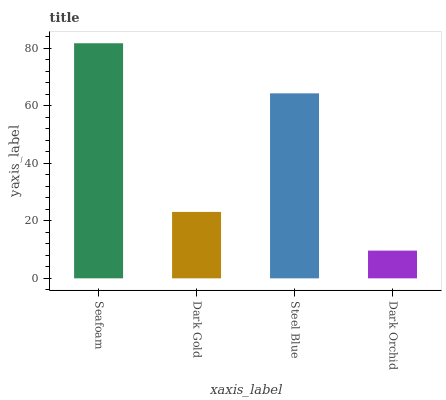Is Dark Orchid the minimum?
Answer yes or no. Yes. Is Seafoam the maximum?
Answer yes or no. Yes. Is Dark Gold the minimum?
Answer yes or no. No. Is Dark Gold the maximum?
Answer yes or no. No. Is Seafoam greater than Dark Gold?
Answer yes or no. Yes. Is Dark Gold less than Seafoam?
Answer yes or no. Yes. Is Dark Gold greater than Seafoam?
Answer yes or no. No. Is Seafoam less than Dark Gold?
Answer yes or no. No. Is Steel Blue the high median?
Answer yes or no. Yes. Is Dark Gold the low median?
Answer yes or no. Yes. Is Seafoam the high median?
Answer yes or no. No. Is Steel Blue the low median?
Answer yes or no. No. 